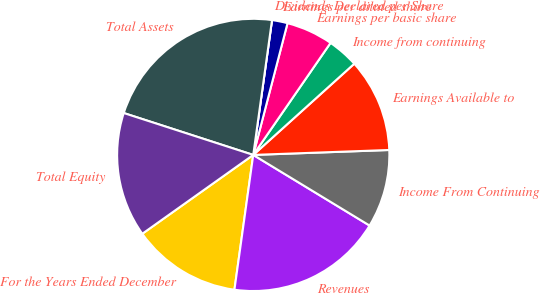Convert chart. <chart><loc_0><loc_0><loc_500><loc_500><pie_chart><fcel>For the Years Ended December<fcel>Revenues<fcel>Income From Continuing<fcel>Earnings Available to<fcel>Income from continuing<fcel>Earnings per basic share<fcel>Earnings per diluted share<fcel>Dividends Declared per Share<fcel>Total Assets<fcel>Total Equity<nl><fcel>12.96%<fcel>18.52%<fcel>9.26%<fcel>11.11%<fcel>3.7%<fcel>5.56%<fcel>1.85%<fcel>0.0%<fcel>22.22%<fcel>14.81%<nl></chart> 